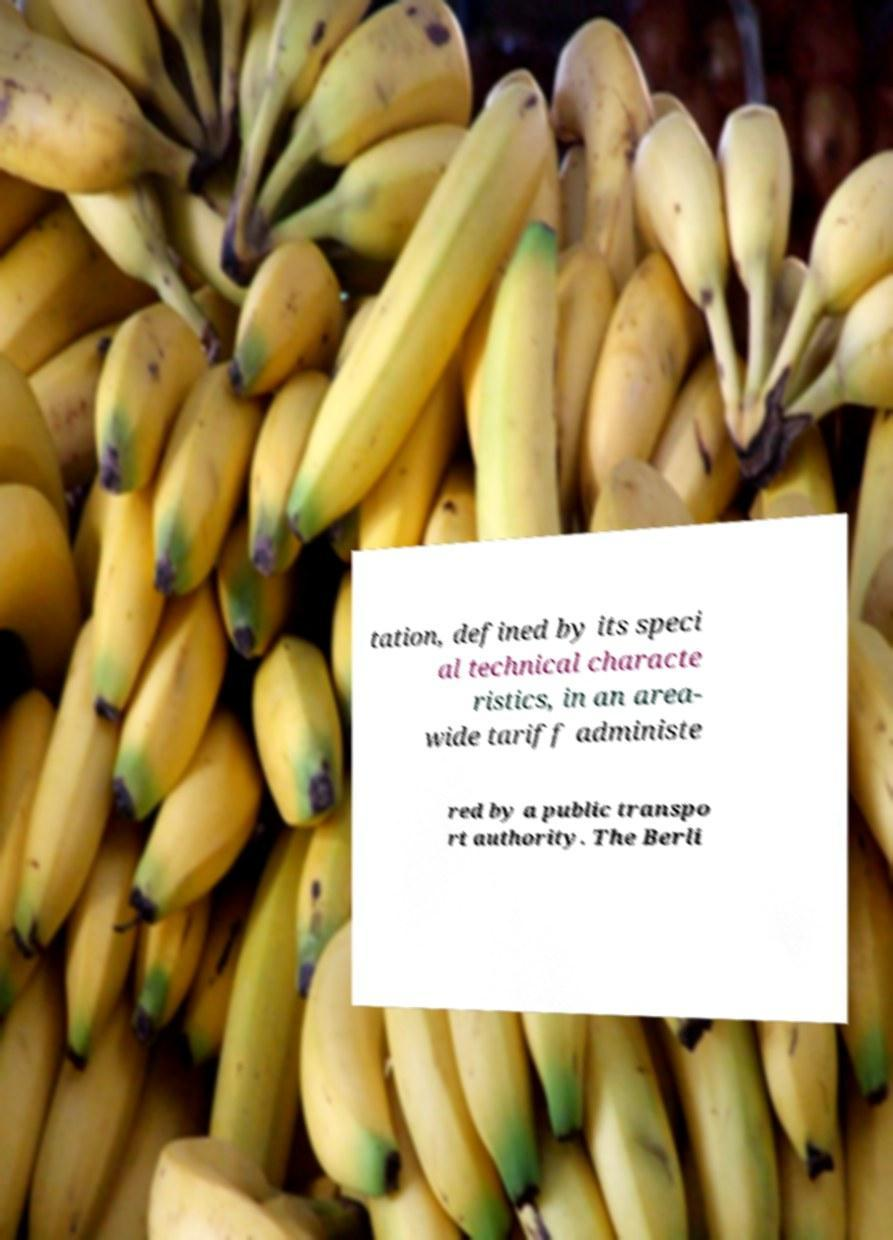Could you extract and type out the text from this image? tation, defined by its speci al technical characte ristics, in an area- wide tariff administe red by a public transpo rt authority. The Berli 